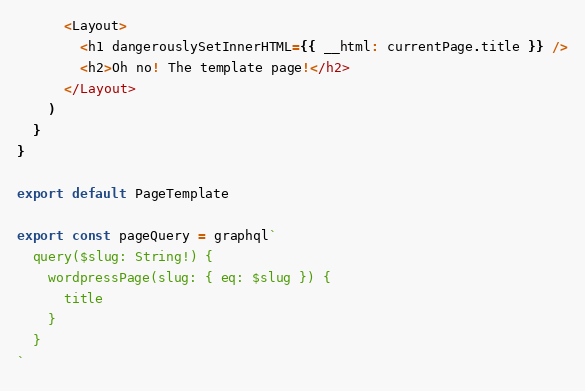Convert code to text. <code><loc_0><loc_0><loc_500><loc_500><_JavaScript_>      <Layout>
        <h1 dangerouslySetInnerHTML={{ __html: currentPage.title }} />
        <h2>Oh no! The template page!</h2>
      </Layout>
    )
  }
}

export default PageTemplate

export const pageQuery = graphql`
  query($slug: String!) {
    wordpressPage(slug: { eq: $slug }) {
      title
    }
  }
`
</code> 